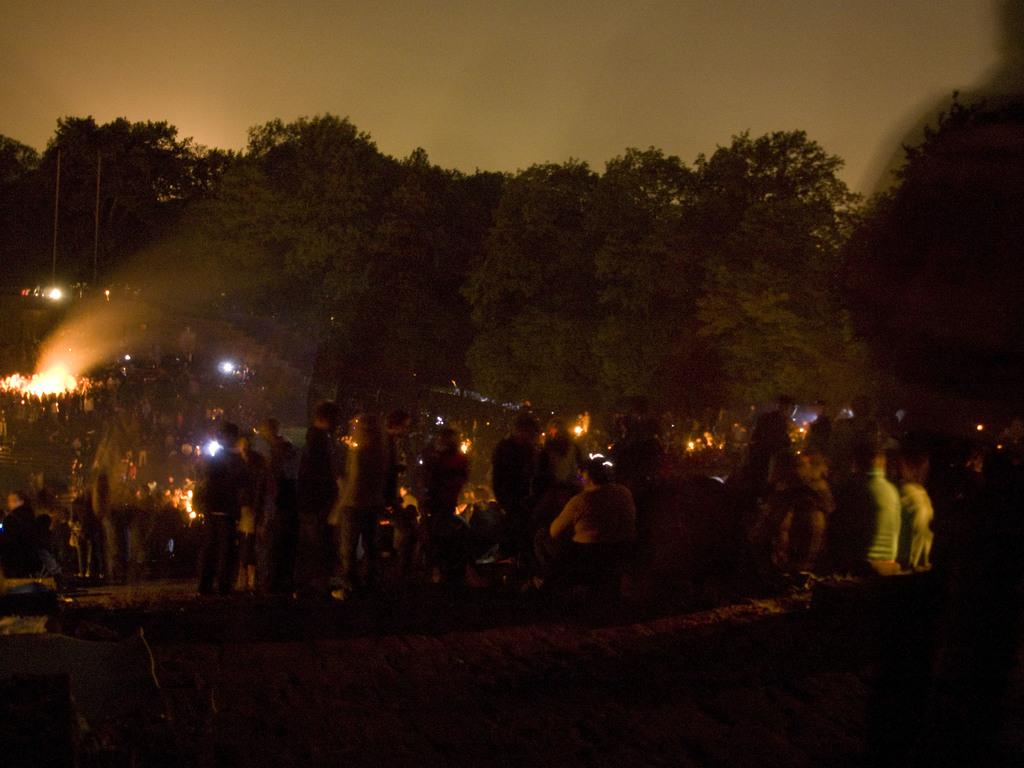What are the people in the image doing? The people in the image are standing on the road. What else can be seen in the image besides the people? There are lights and trees visible in the image. What is the condition of the sky in the image? The sky is clear in the image. How would you describe the lighting in the image? The image appears to be slightly dark. Which knee is twisted in the image? There are no knees or twisting actions present in the image. 